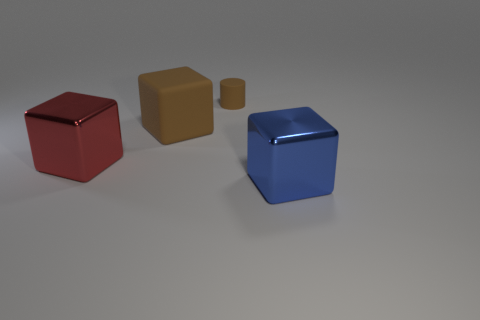Add 4 big brown blocks. How many objects exist? 8 Subtract all cubes. How many objects are left? 1 Add 3 big red shiny cubes. How many big red shiny cubes are left? 4 Add 3 metal things. How many metal things exist? 5 Subtract 0 gray cylinders. How many objects are left? 4 Subtract all small red cubes. Subtract all shiny blocks. How many objects are left? 2 